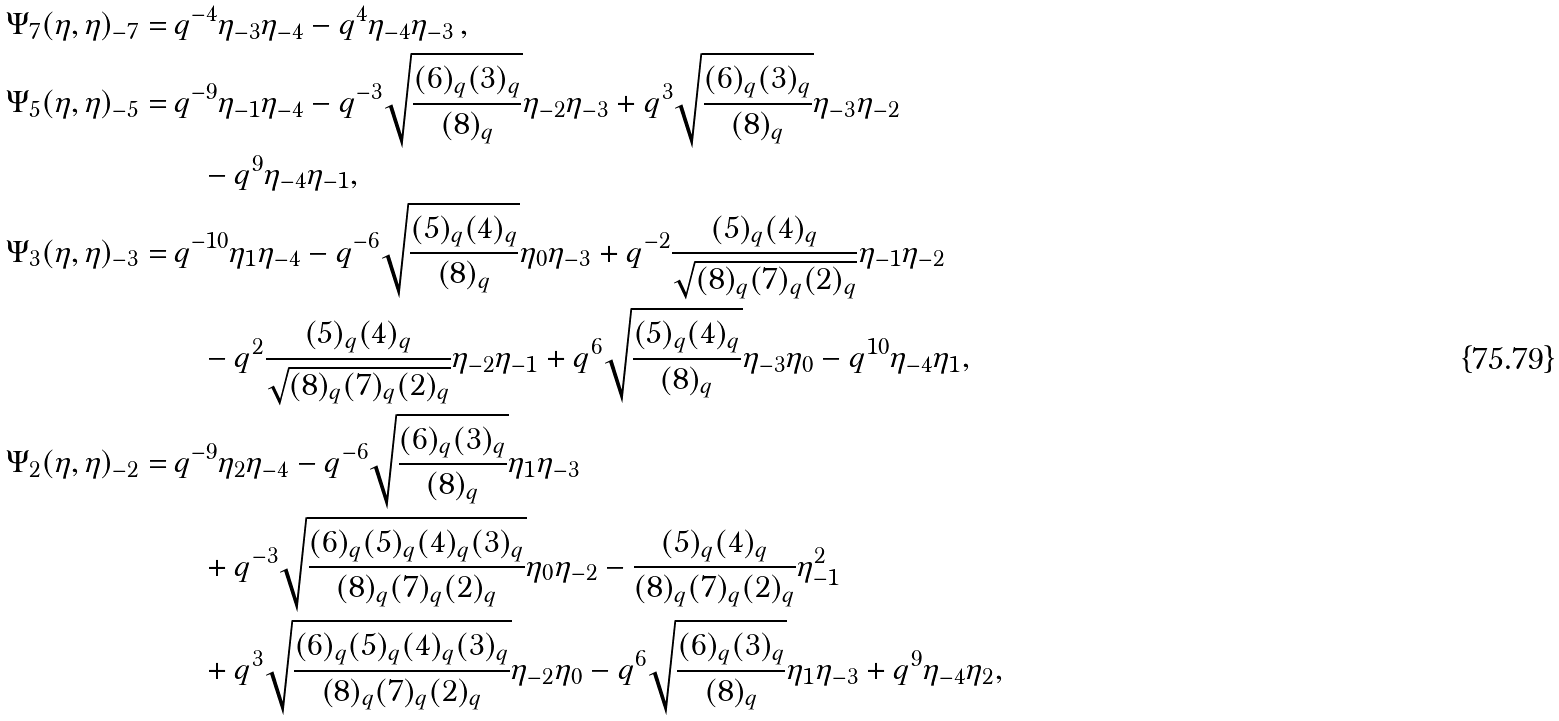Convert formula to latex. <formula><loc_0><loc_0><loc_500><loc_500>\Psi _ { 7 } ( \eta , \eta ) _ { - 7 } = & \, q ^ { - 4 } \eta _ { - 3 } \eta _ { - 4 } - q ^ { 4 } \eta _ { - 4 } \eta _ { - 3 } \, , \\ \Psi _ { 5 } ( \eta , \eta ) _ { - 5 } = & \, q ^ { - 9 } \eta _ { - 1 } \eta _ { - 4 } - q ^ { - 3 } \sqrt { \frac { ( 6 ) _ { q } ( 3 ) _ { q } } { ( 8 ) _ { q } } } \eta _ { - 2 } \eta _ { - 3 } + q ^ { 3 } \sqrt { \frac { ( 6 ) _ { q } ( 3 ) _ { q } } { ( 8 ) _ { q } } } \eta _ { - 3 } \eta _ { - 2 } \\ & \quad - q ^ { 9 } \eta _ { - 4 } \eta _ { - 1 } , \\ \Psi _ { 3 } ( \eta , \eta ) _ { - 3 } = & \, q ^ { - 1 0 } \eta _ { 1 } \eta _ { - 4 } - q ^ { - 6 } \sqrt { \frac { ( 5 ) _ { q } ( 4 ) _ { q } } { ( 8 ) _ { q } } } \eta _ { 0 } \eta _ { - 3 } + q ^ { - 2 } \frac { ( 5 ) _ { q } ( 4 ) _ { q } } { \sqrt { ( 8 ) _ { q } ( 7 ) _ { q } ( 2 ) _ { q } } } \eta _ { - 1 } \eta _ { - 2 } \\ & \quad - q ^ { 2 } \frac { ( 5 ) _ { q } ( 4 ) _ { q } } { \sqrt { ( 8 ) _ { q } ( 7 ) _ { q } ( 2 ) _ { q } } } \eta _ { - 2 } \eta _ { - 1 } + q ^ { 6 } \sqrt { \frac { ( 5 ) _ { q } ( 4 ) _ { q } } { ( 8 ) _ { q } } } \eta _ { - 3 } \eta _ { 0 } - q ^ { 1 0 } \eta _ { - 4 } \eta _ { 1 } , \\ \Psi _ { 2 } ( \eta , \eta ) _ { - 2 } = & \, q ^ { - 9 } \eta _ { 2 } \eta _ { - 4 } - q ^ { - 6 } \sqrt { \frac { ( 6 ) _ { q } ( 3 ) _ { q } } { ( 8 ) _ { q } } } \eta _ { 1 } \eta _ { - 3 } \\ & \quad + q ^ { - 3 } \sqrt { \frac { ( 6 ) _ { q } ( 5 ) _ { q } ( 4 ) _ { q } ( 3 ) _ { q } } { ( 8 ) _ { q } ( 7 ) _ { q } ( 2 ) _ { q } } } \eta _ { 0 } \eta _ { - 2 } - \frac { ( 5 ) _ { q } ( 4 ) _ { q } } { ( 8 ) _ { q } ( 7 ) _ { q } ( 2 ) _ { q } } \eta _ { - 1 } ^ { 2 } \\ & \quad + q ^ { 3 } \sqrt { \frac { ( 6 ) _ { q } ( 5 ) _ { q } ( 4 ) _ { q } ( 3 ) _ { q } } { ( 8 ) _ { q } ( 7 ) _ { q } ( 2 ) _ { q } } } \eta _ { - 2 } \eta _ { 0 } - q ^ { 6 } \sqrt { \frac { ( 6 ) _ { q } ( 3 ) _ { q } } { ( 8 ) _ { q } } } \eta _ { 1 } \eta _ { - 3 } + q ^ { 9 } \eta _ { - 4 } \eta _ { 2 } ,</formula> 